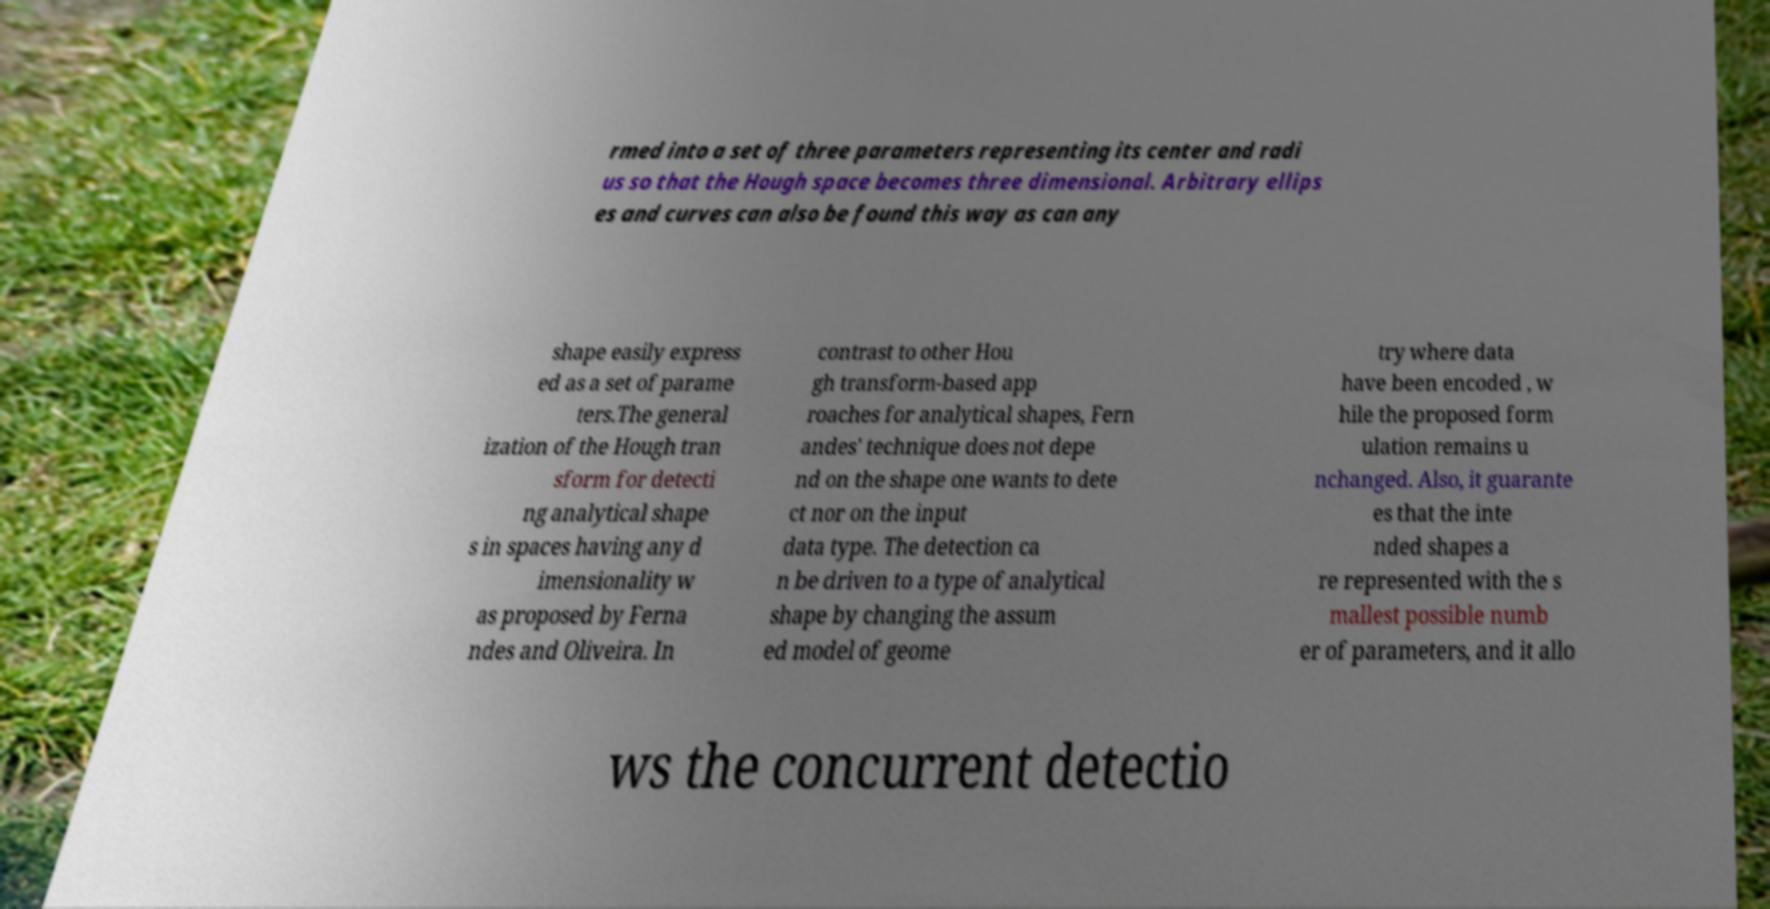I need the written content from this picture converted into text. Can you do that? rmed into a set of three parameters representing its center and radi us so that the Hough space becomes three dimensional. Arbitrary ellips es and curves can also be found this way as can any shape easily express ed as a set of parame ters.The general ization of the Hough tran sform for detecti ng analytical shape s in spaces having any d imensionality w as proposed by Ferna ndes and Oliveira. In contrast to other Hou gh transform-based app roaches for analytical shapes, Fern andes' technique does not depe nd on the shape one wants to dete ct nor on the input data type. The detection ca n be driven to a type of analytical shape by changing the assum ed model of geome try where data have been encoded , w hile the proposed form ulation remains u nchanged. Also, it guarante es that the inte nded shapes a re represented with the s mallest possible numb er of parameters, and it allo ws the concurrent detectio 